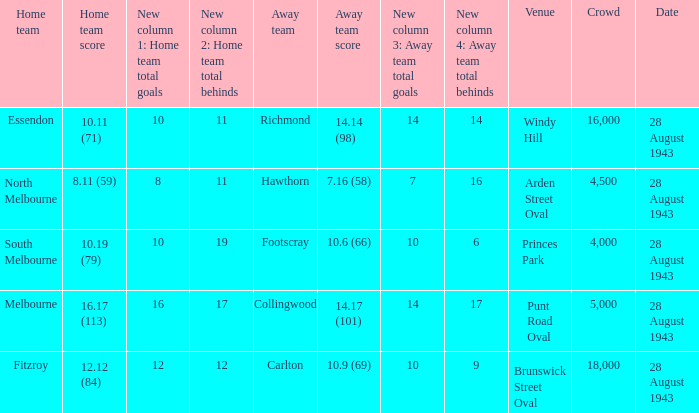Where was the game played with an away team score of 14.17 (101)? Punt Road Oval. 